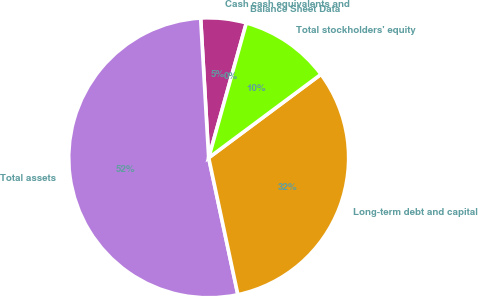Convert chart to OTSL. <chart><loc_0><loc_0><loc_500><loc_500><pie_chart><fcel>Balance Sheet Data<fcel>Cash cash equivalents and<fcel>Total assets<fcel>Long-term debt and capital<fcel>Total stockholders' equity<nl><fcel>0.0%<fcel>5.25%<fcel>52.43%<fcel>31.83%<fcel>10.49%<nl></chart> 